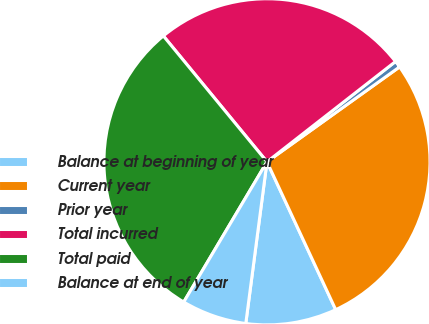Convert chart to OTSL. <chart><loc_0><loc_0><loc_500><loc_500><pie_chart><fcel>Balance at beginning of year<fcel>Current year<fcel>Prior year<fcel>Total incurred<fcel>Total paid<fcel>Balance at end of year<nl><fcel>9.0%<fcel>27.96%<fcel>0.66%<fcel>25.41%<fcel>30.51%<fcel>6.45%<nl></chart> 